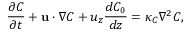<formula> <loc_0><loc_0><loc_500><loc_500>\frac { \partial C } { \partial t } + u \cdot \nabla C + u _ { z } \frac { d C _ { 0 } } { d z } = \kappa _ { C } \nabla ^ { 2 } C ,</formula> 